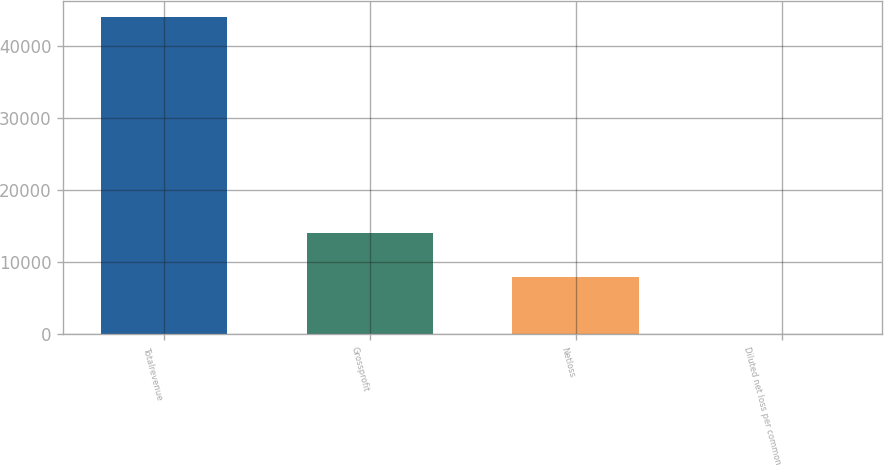Convert chart to OTSL. <chart><loc_0><loc_0><loc_500><loc_500><bar_chart><fcel>Totalrevenue<fcel>Grossprofit<fcel>Netloss<fcel>Diluted net loss per common<nl><fcel>44090<fcel>14099<fcel>7945<fcel>0.51<nl></chart> 